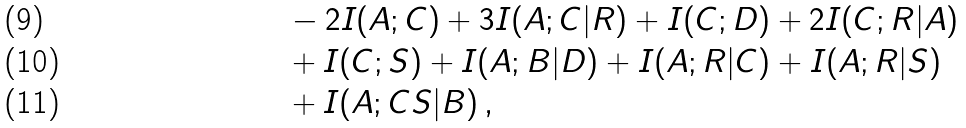Convert formula to latex. <formula><loc_0><loc_0><loc_500><loc_500>& \ \ - 2 I ( A ; C ) + 3 I ( A ; C | R ) + I ( C ; D ) + 2 I ( C ; R | A ) \\ & \ \ + I ( C ; S ) + I ( A ; B | D ) + I ( A ; R | C ) + I ( A ; R | S ) \\ & \ \ + I ( A ; C S | B ) \, ,</formula> 